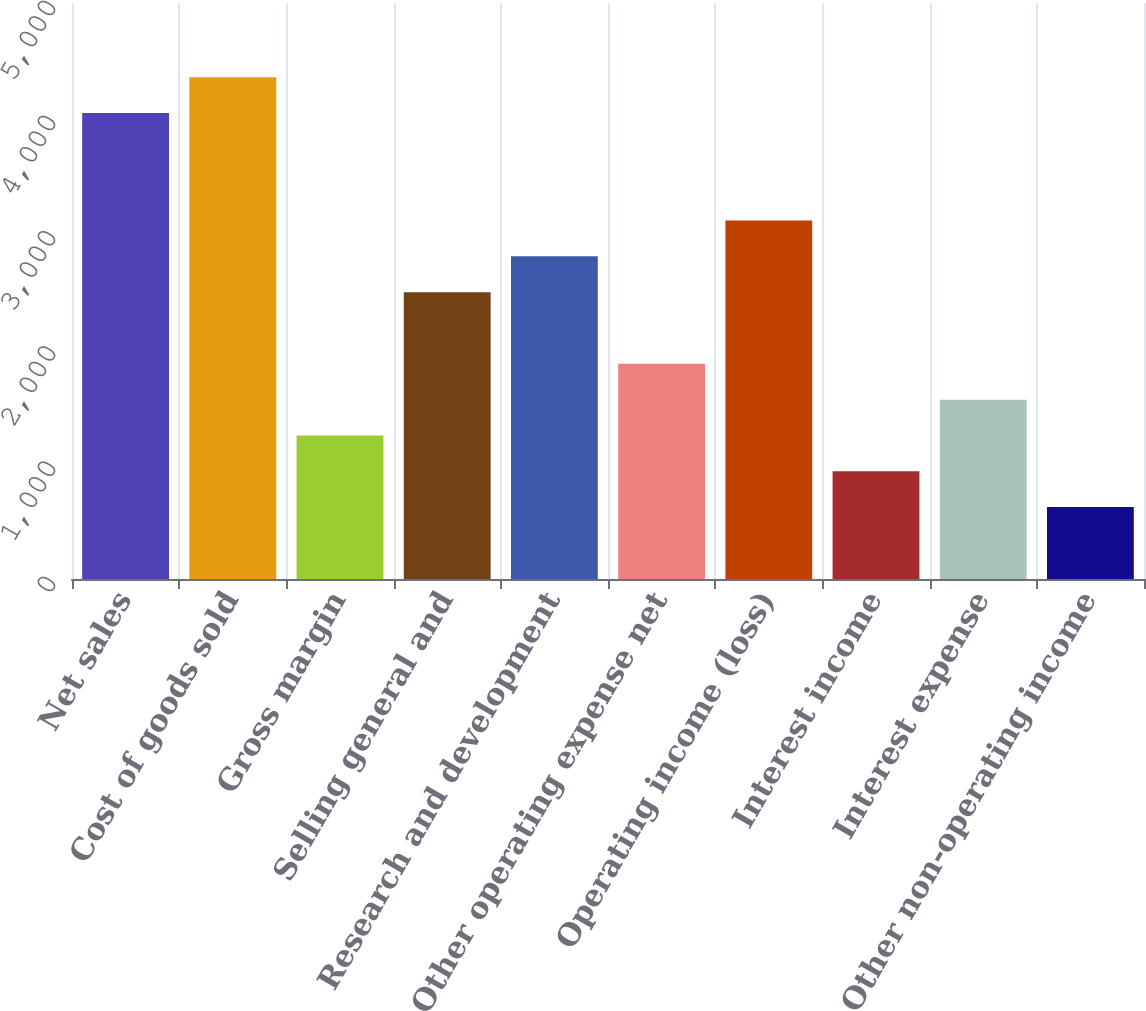Convert chart. <chart><loc_0><loc_0><loc_500><loc_500><bar_chart><fcel>Net sales<fcel>Cost of goods sold<fcel>Gross margin<fcel>Selling general and<fcel>Research and development<fcel>Other operating expense net<fcel>Operating income (loss)<fcel>Interest income<fcel>Interest expense<fcel>Other non-operating income<nl><fcel>4044.98<fcel>4355.97<fcel>1246.07<fcel>2490.03<fcel>2801.02<fcel>1868.05<fcel>3112.01<fcel>935.08<fcel>1557.06<fcel>624.09<nl></chart> 